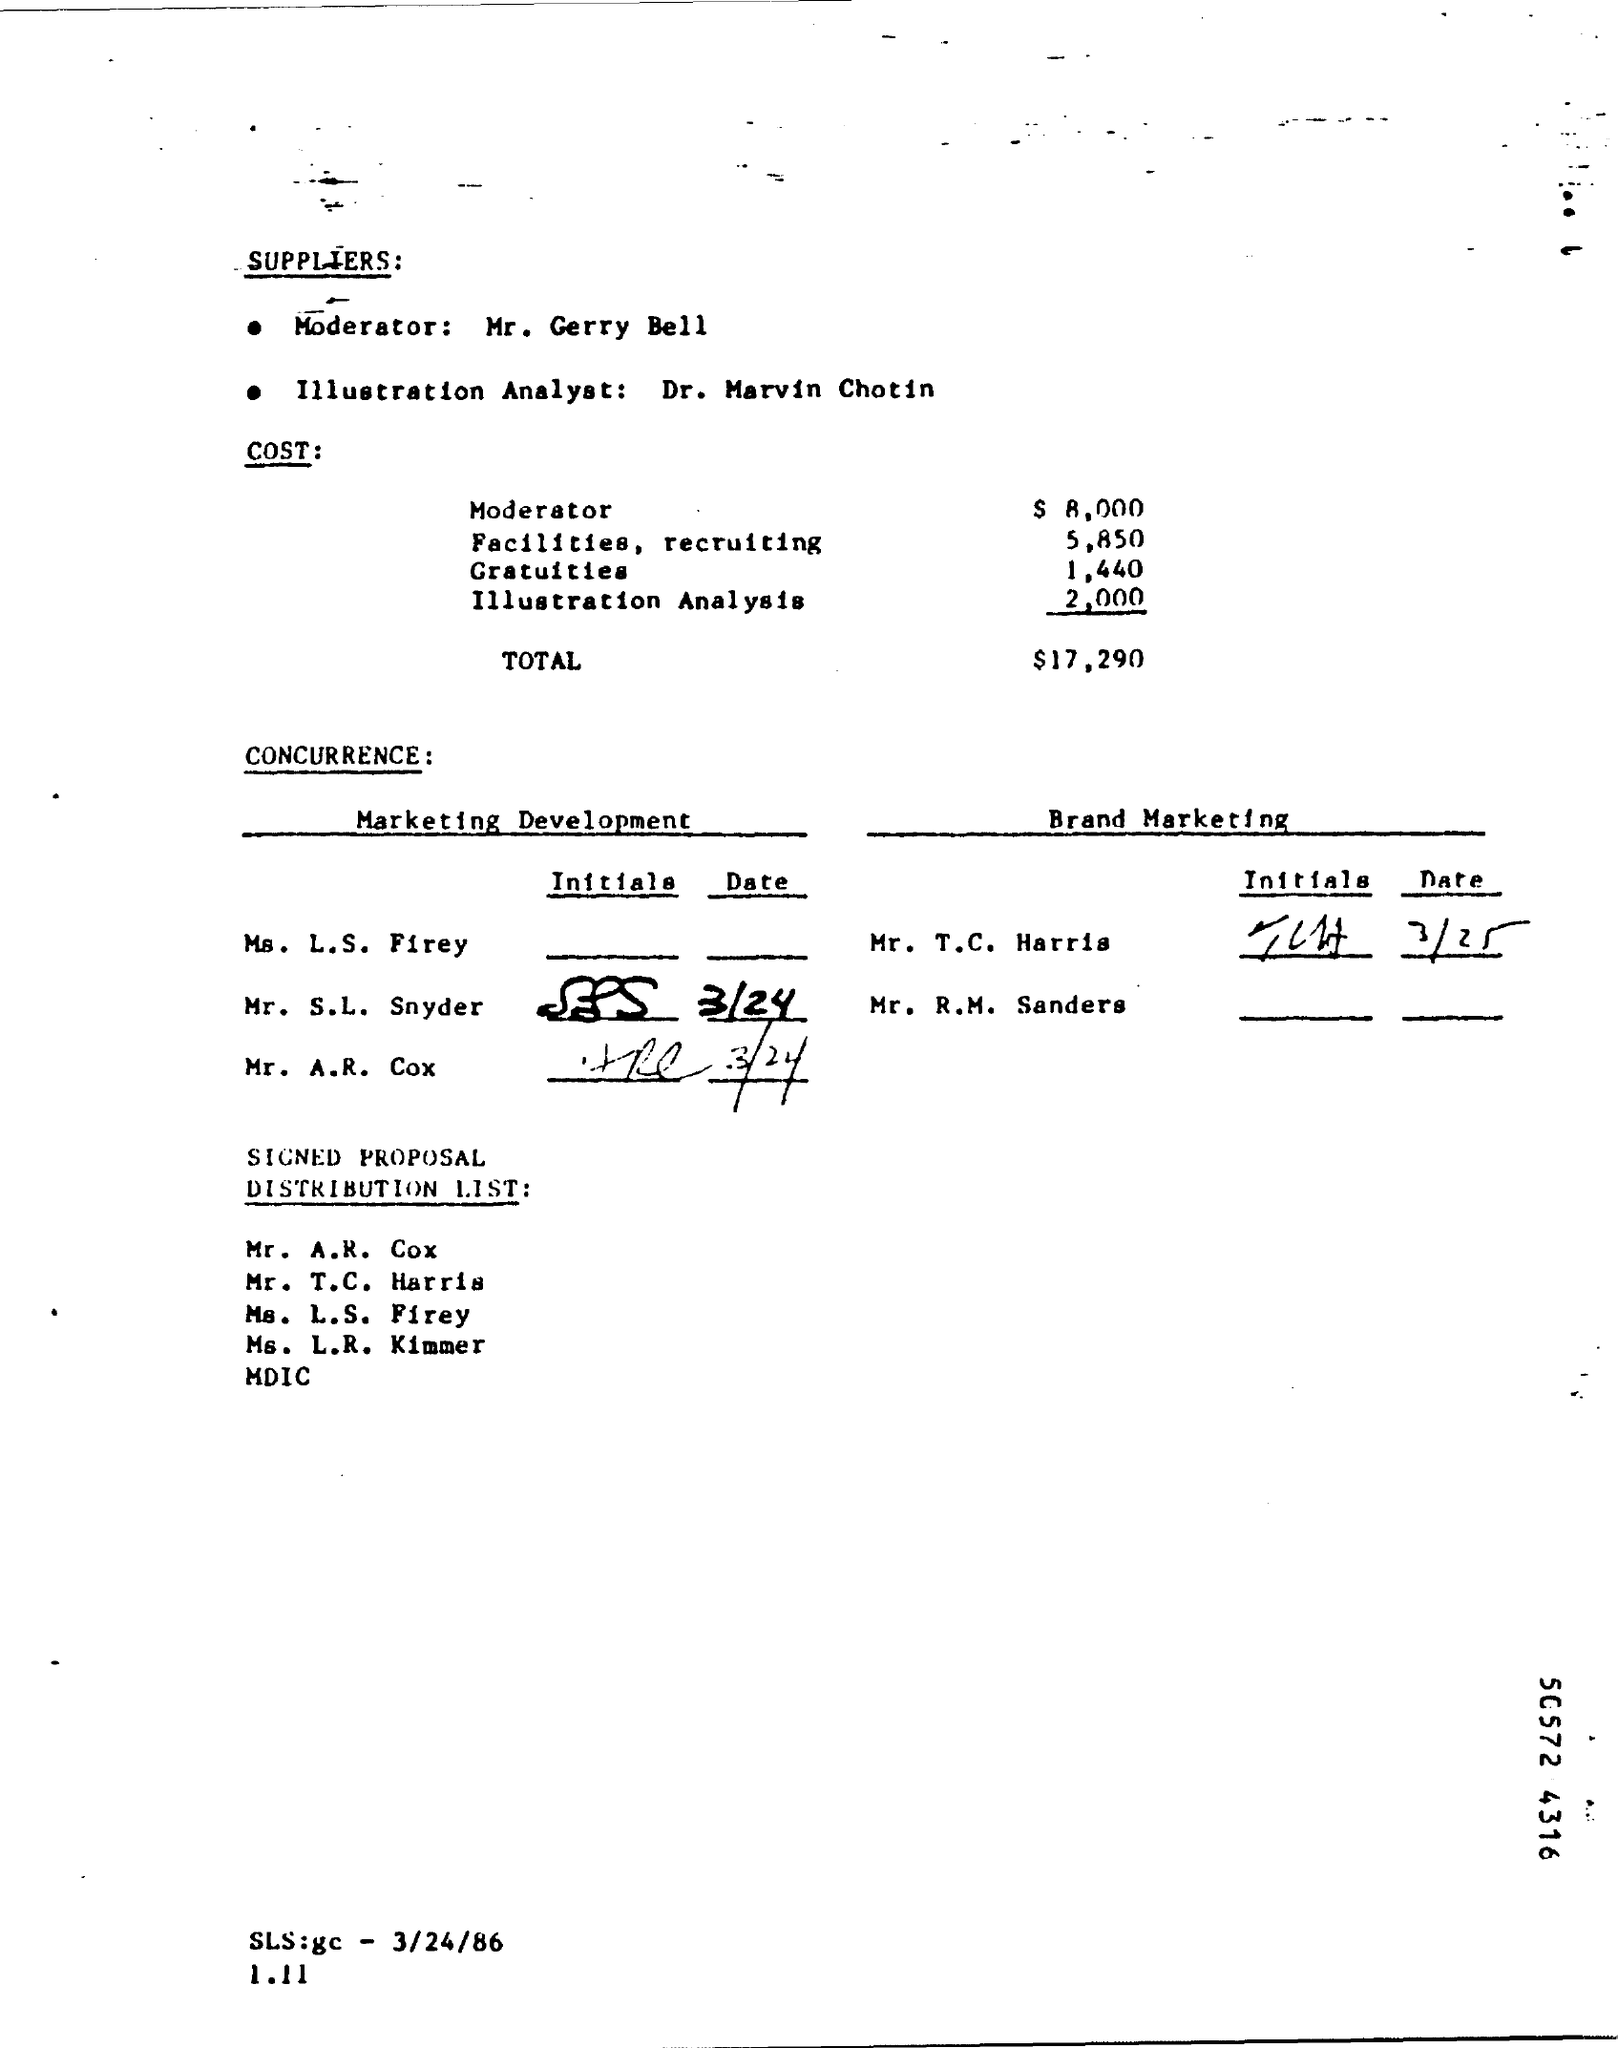Draw attention to some important aspects in this diagram. According to the provided page, the total cost is $17,290. The given page mentions a gratuities amount of 1,440. The cost of illustration analysis is approximately $2,000. As stated on the given page, the cost of a moderator is 8,000. 